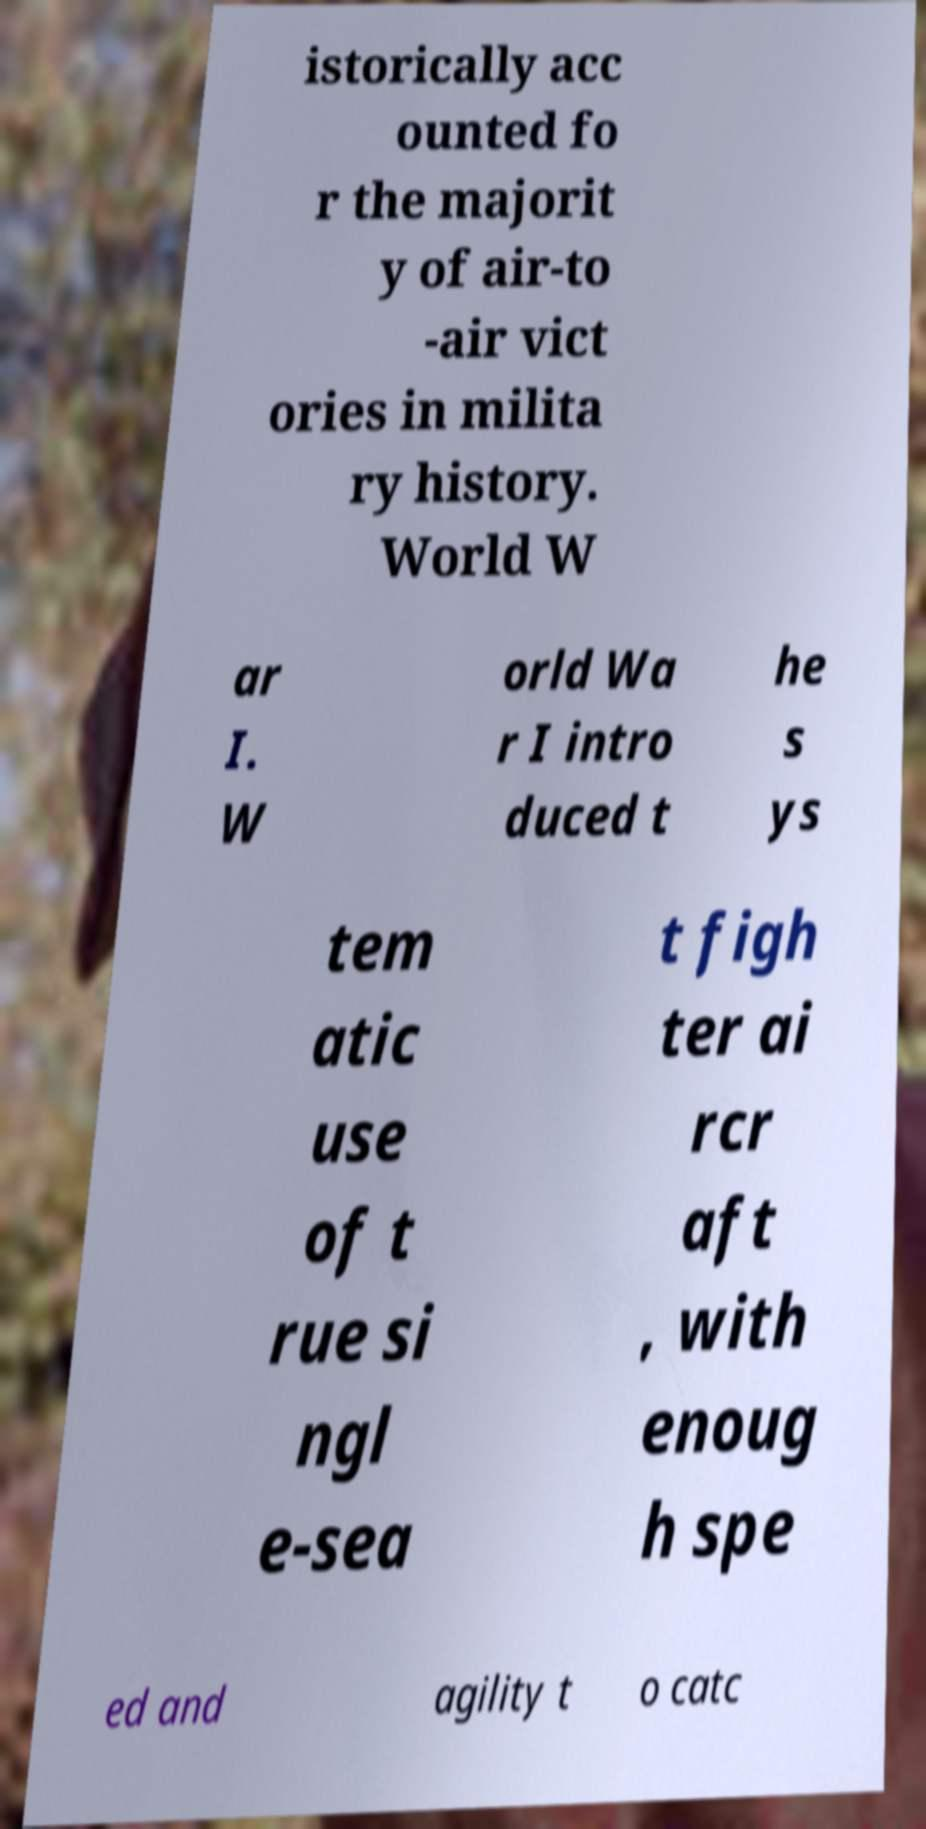Please read and relay the text visible in this image. What does it say? istorically acc ounted fo r the majorit y of air-to -air vict ories in milita ry history. World W ar I. W orld Wa r I intro duced t he s ys tem atic use of t rue si ngl e-sea t figh ter ai rcr aft , with enoug h spe ed and agility t o catc 